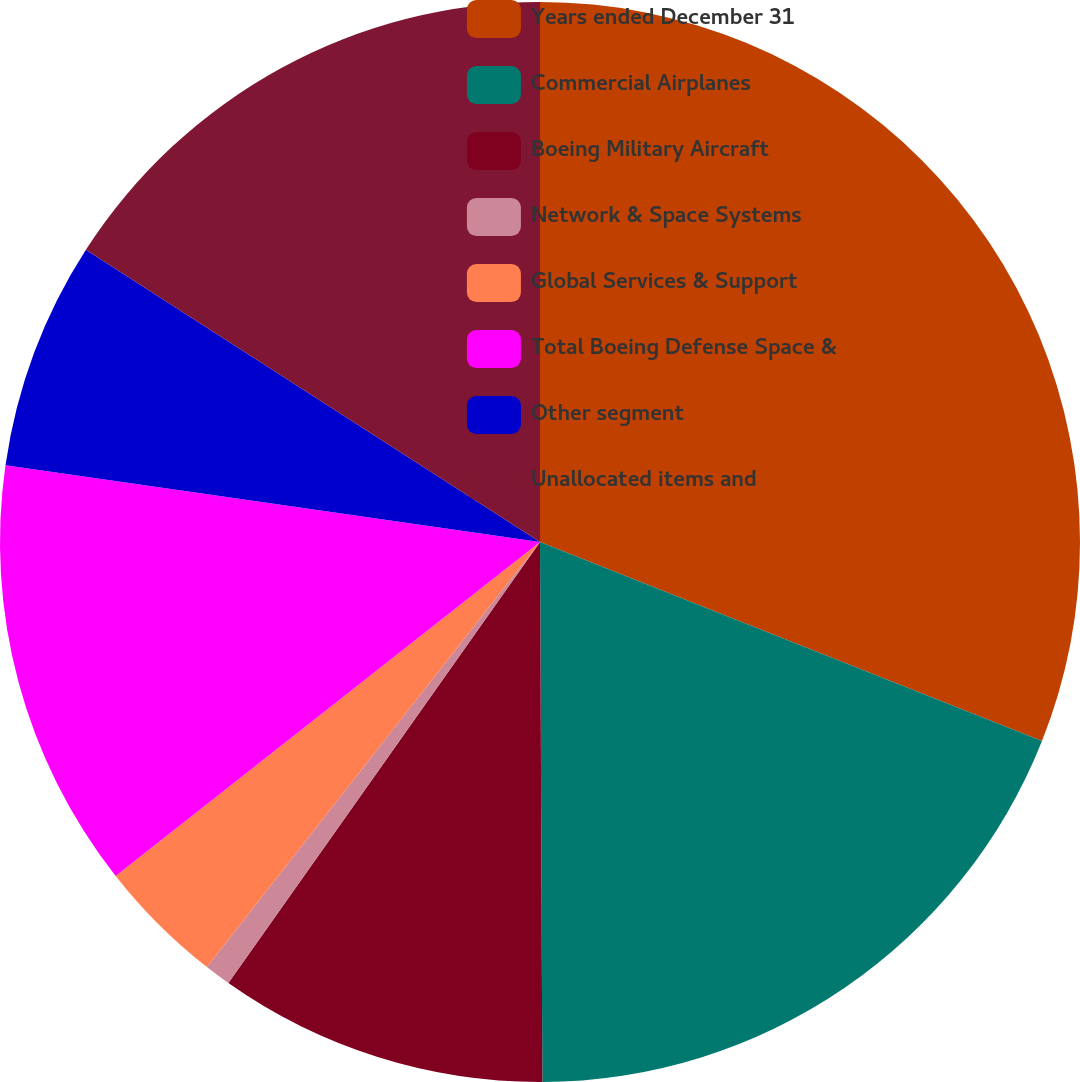Convert chart. <chart><loc_0><loc_0><loc_500><loc_500><pie_chart><fcel>Years ended December 31<fcel>Commercial Airplanes<fcel>Boeing Military Aircraft<fcel>Network & Space Systems<fcel>Global Services & Support<fcel>Total Boeing Defense Space &<fcel>Other segment<fcel>Unallocated items and<nl><fcel>31.01%<fcel>18.92%<fcel>9.86%<fcel>0.79%<fcel>3.81%<fcel>12.88%<fcel>6.83%<fcel>15.9%<nl></chart> 